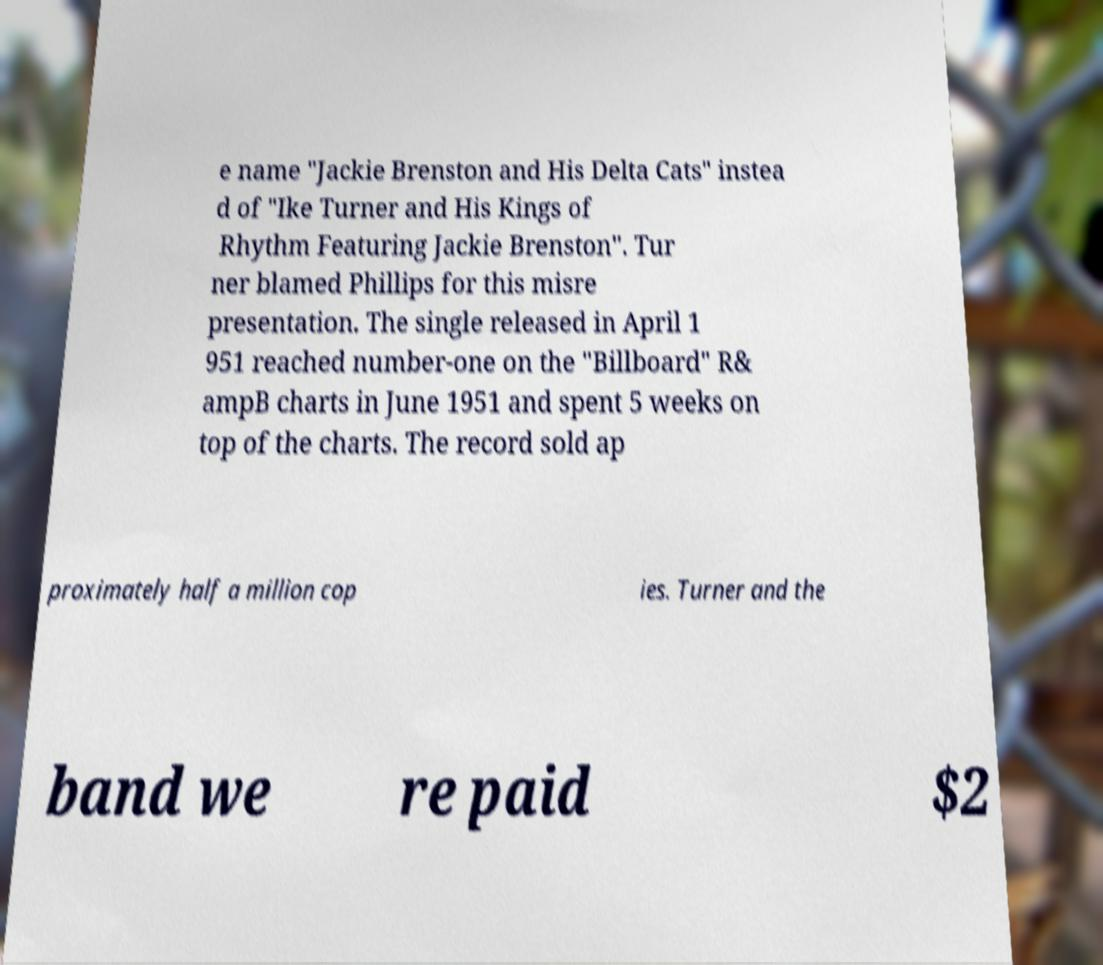For documentation purposes, I need the text within this image transcribed. Could you provide that? e name "Jackie Brenston and His Delta Cats" instea d of "Ike Turner and His Kings of Rhythm Featuring Jackie Brenston". Tur ner blamed Phillips for this misre presentation. The single released in April 1 951 reached number-one on the "Billboard" R& ampB charts in June 1951 and spent 5 weeks on top of the charts. The record sold ap proximately half a million cop ies. Turner and the band we re paid $2 